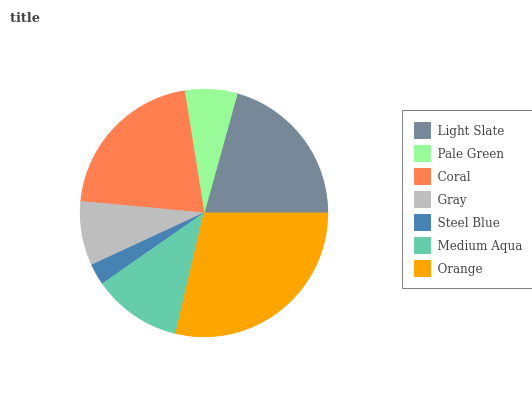Is Steel Blue the minimum?
Answer yes or no. Yes. Is Orange the maximum?
Answer yes or no. Yes. Is Pale Green the minimum?
Answer yes or no. No. Is Pale Green the maximum?
Answer yes or no. No. Is Light Slate greater than Pale Green?
Answer yes or no. Yes. Is Pale Green less than Light Slate?
Answer yes or no. Yes. Is Pale Green greater than Light Slate?
Answer yes or no. No. Is Light Slate less than Pale Green?
Answer yes or no. No. Is Medium Aqua the high median?
Answer yes or no. Yes. Is Medium Aqua the low median?
Answer yes or no. Yes. Is Gray the high median?
Answer yes or no. No. Is Light Slate the low median?
Answer yes or no. No. 